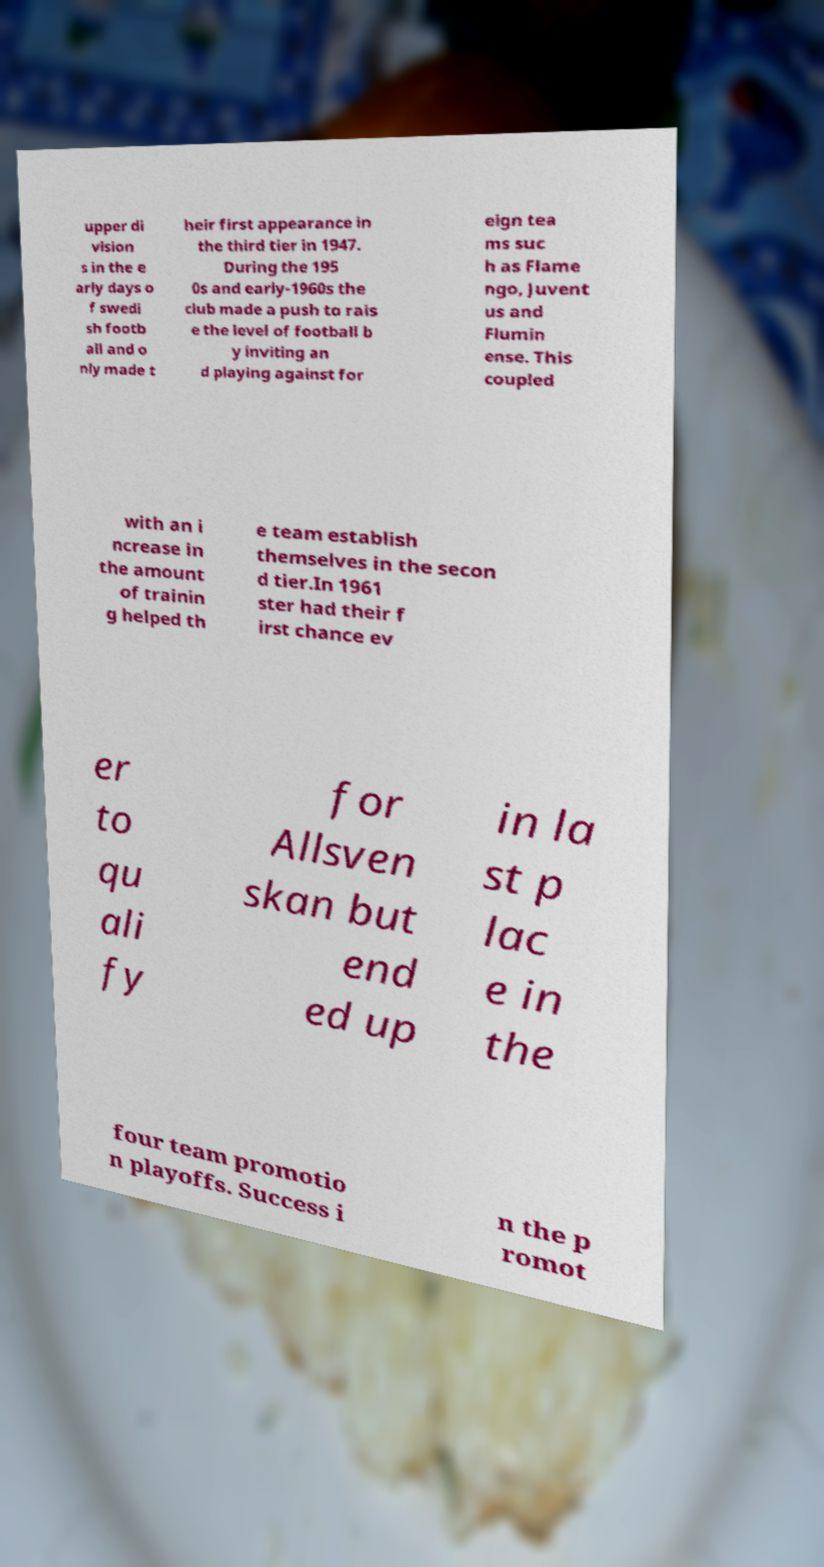I need the written content from this picture converted into text. Can you do that? upper di vision s in the e arly days o f swedi sh footb all and o nly made t heir first appearance in the third tier in 1947. During the 195 0s and early-1960s the club made a push to rais e the level of football b y inviting an d playing against for eign tea ms suc h as Flame ngo, Juvent us and Flumin ense. This coupled with an i ncrease in the amount of trainin g helped th e team establish themselves in the secon d tier.In 1961 ster had their f irst chance ev er to qu ali fy for Allsven skan but end ed up in la st p lac e in the four team promotio n playoffs. Success i n the p romot 